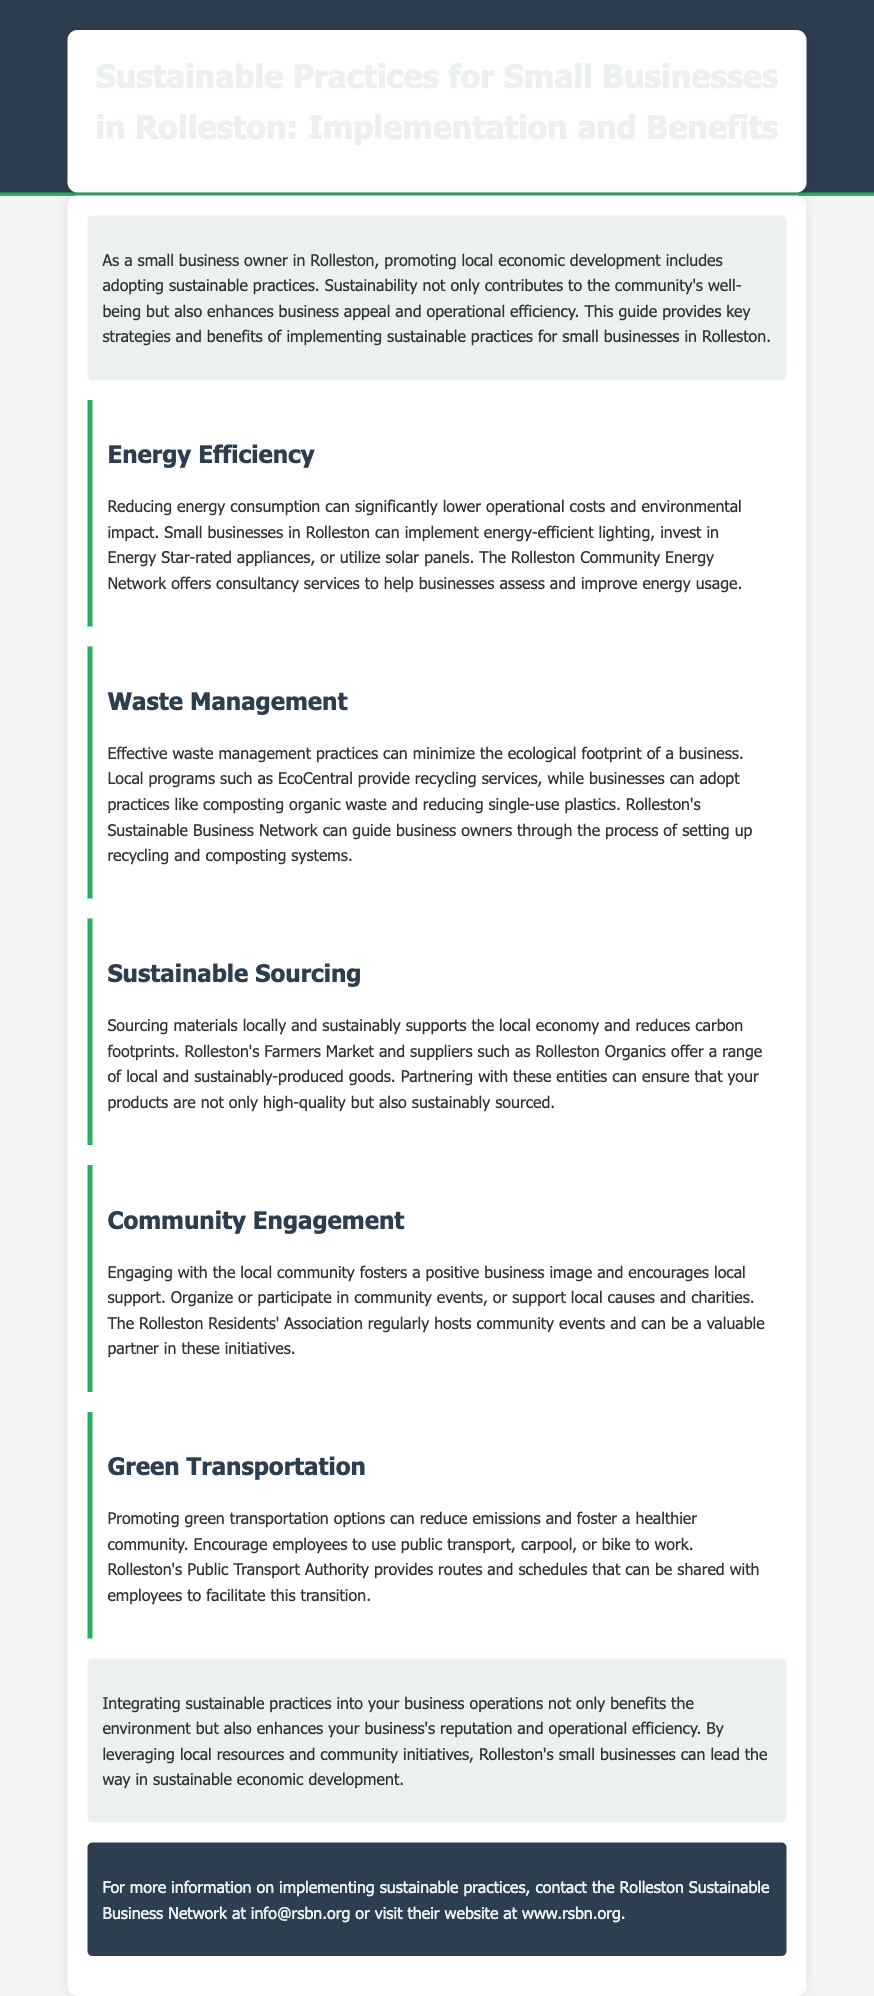What is the title of the guide? The title of the guide is presented prominently in the header section of the document.
Answer: Sustainable Practices for Small Businesses in Rolleston: Implementation and Benefits What organization offers consultancy services for energy usage? The document mentions a specific organization that provides consultancy to help improve energy usage.
Answer: Rolleston Community Energy Network Which practice can minimize the ecological footprint of a business? The guide lists various practices that help reduce impact on the environment, including one specific practice.
Answer: Waste Management What local market supports sustainable sourcing? The document cites a local market that provides sustainably produced goods for businesses.
Answer: Rolleston's Farmers Market What is one benefit of engaging with the local community? The guide discusses the positive effects of community engagement for businesses, highlighting a particular type of benefit.
Answer: Positive business image How can businesses promote green transportation? A method is suggested within the document for encouraging employees to adopt eco-friendly transportation options.
Answer: Encourage public transport What can be set up to support effective waste management? The document refers to a way through which businesses can enhance their waste management efforts.
Answer: Recycling and composting systems What does the document suggest as a conclusion about sustainable practices? The concluding statement summarizes the overall takeaway regarding the benefits of sustainability in operations.
Answer: Benefits the environment Where can one find more information on sustainable practices? The guide details the contact information for further inquiries on sustainable practices.
Answer: info@rsbn.org 